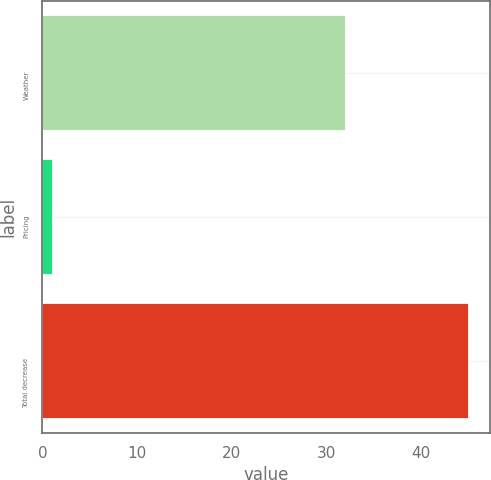Convert chart. <chart><loc_0><loc_0><loc_500><loc_500><bar_chart><fcel>Weather<fcel>Pricing<fcel>Total decrease<nl><fcel>32<fcel>1<fcel>45<nl></chart> 